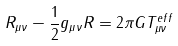<formula> <loc_0><loc_0><loc_500><loc_500>R _ { \mu \nu } - \frac { 1 } { 2 } g _ { \mu \nu } R = 2 \pi G T _ { \mu \nu } ^ { e f f }</formula> 